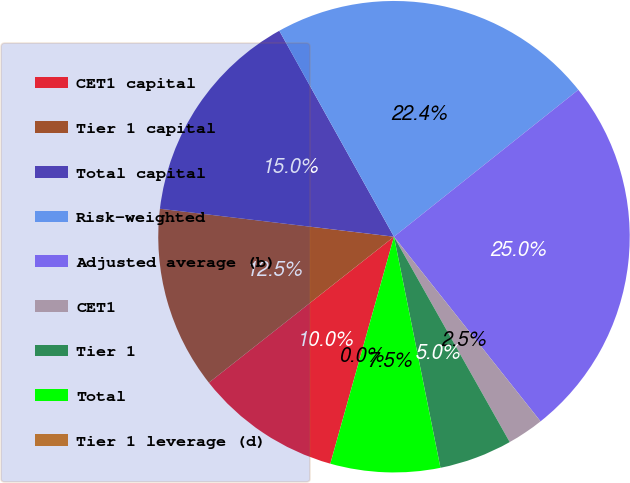Convert chart. <chart><loc_0><loc_0><loc_500><loc_500><pie_chart><fcel>CET1 capital<fcel>Tier 1 capital<fcel>Total capital<fcel>Risk-weighted<fcel>Adjusted average (b)<fcel>CET1<fcel>Tier 1<fcel>Total<fcel>Tier 1 leverage (d)<nl><fcel>10.02%<fcel>12.52%<fcel>15.02%<fcel>22.38%<fcel>25.03%<fcel>2.51%<fcel>5.01%<fcel>7.51%<fcel>0.0%<nl></chart> 